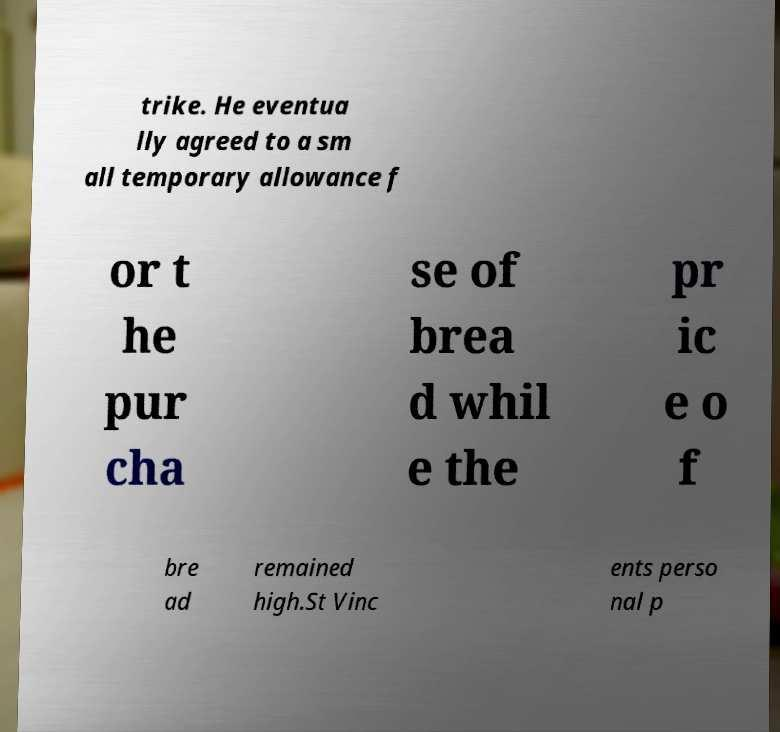For documentation purposes, I need the text within this image transcribed. Could you provide that? trike. He eventua lly agreed to a sm all temporary allowance f or t he pur cha se of brea d whil e the pr ic e o f bre ad remained high.St Vinc ents perso nal p 